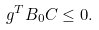<formula> <loc_0><loc_0><loc_500><loc_500>g ^ { T } B _ { 0 } C \leq 0 .</formula> 